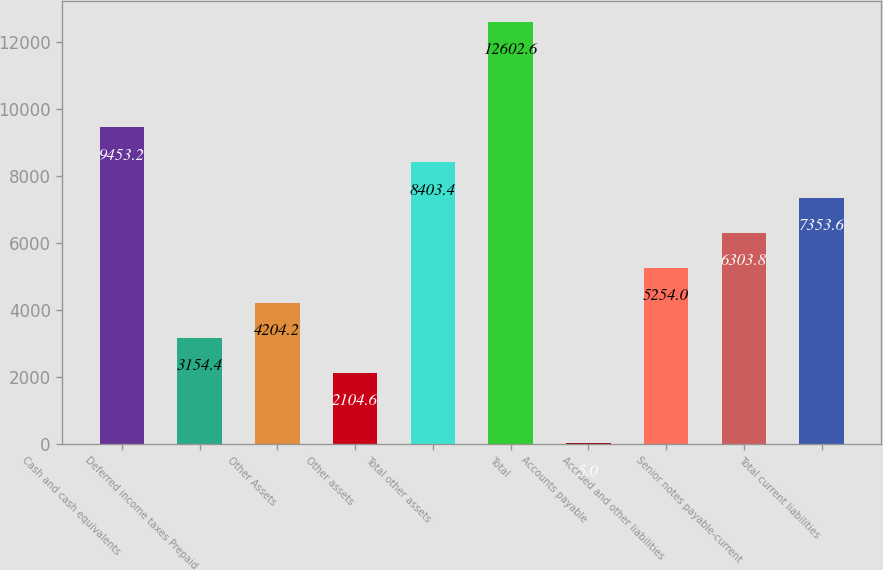<chart> <loc_0><loc_0><loc_500><loc_500><bar_chart><fcel>Cash and cash equivalents<fcel>Deferred income taxes Prepaid<fcel>Other Assets<fcel>Other assets<fcel>Total other assets<fcel>Total<fcel>Accounts payable<fcel>Accrued and other liabilities<fcel>Senior notes payable-current<fcel>Total current liabilities<nl><fcel>9453.2<fcel>3154.4<fcel>4204.2<fcel>2104.6<fcel>8403.4<fcel>12602.6<fcel>5<fcel>5254<fcel>6303.8<fcel>7353.6<nl></chart> 